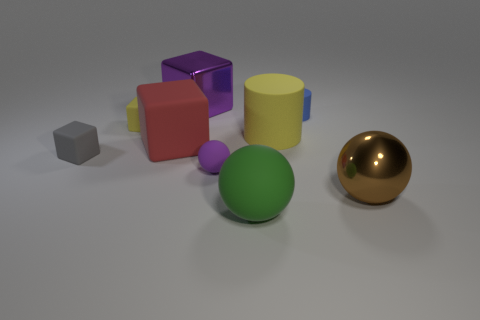What is the shape of the small object that is the same color as the large rubber cylinder?
Keep it short and to the point. Cube. What number of objects are either small purple balls or objects that are behind the big brown metal sphere?
Offer a very short reply. 7. What is the size of the purple thing that is in front of the gray matte object?
Your answer should be very brief. Small. Are there fewer yellow matte objects in front of the gray thing than small rubber cylinders to the left of the tiny purple sphere?
Keep it short and to the point. No. What material is the big object that is both behind the red matte thing and on the right side of the tiny sphere?
Give a very brief answer. Rubber. There is a brown shiny object that is right of the small thing to the right of the large matte sphere; what shape is it?
Your response must be concise. Sphere. Does the small matte cylinder have the same color as the metallic sphere?
Offer a very short reply. No. What number of gray objects are either metal objects or small matte objects?
Provide a succinct answer. 1. Are there any large purple things to the left of the yellow rubber cube?
Provide a short and direct response. No. The metallic block has what size?
Offer a very short reply. Large. 